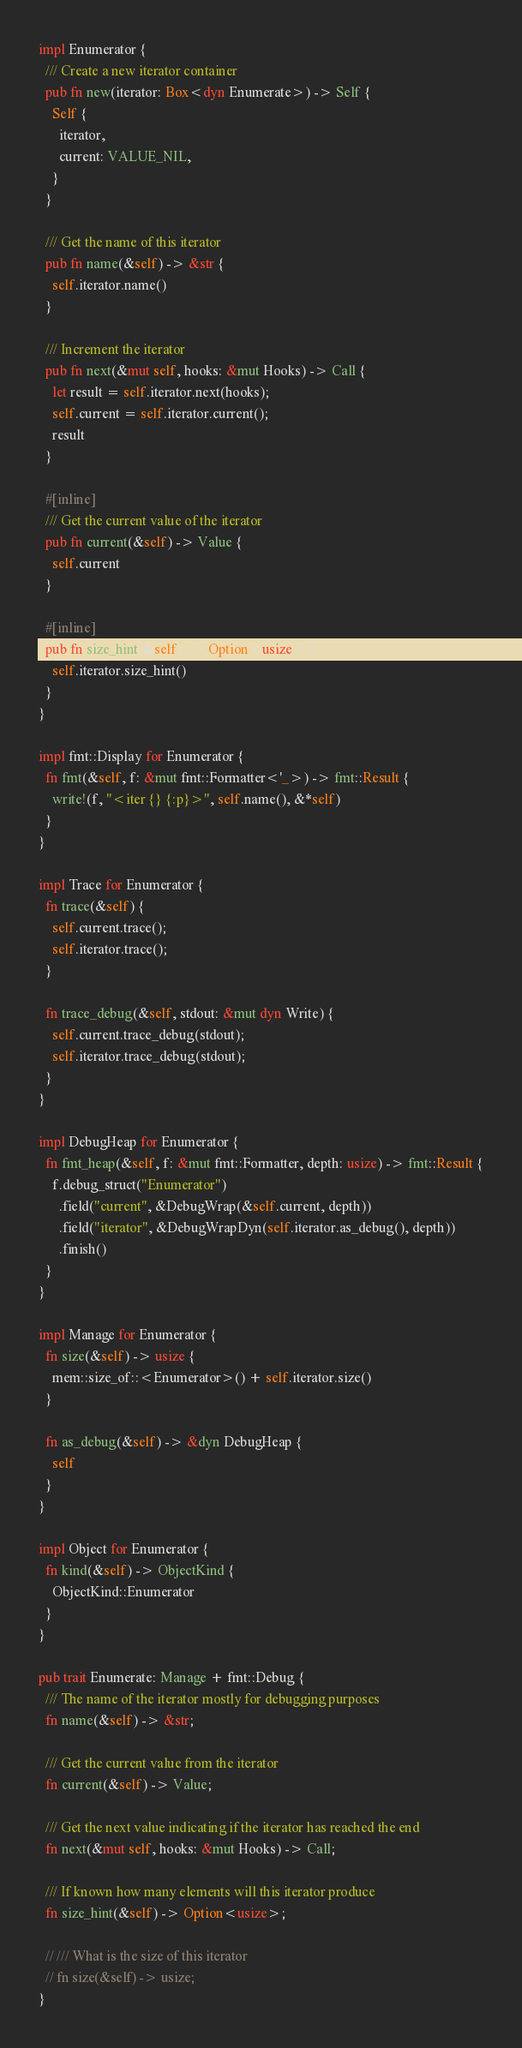Convert code to text. <code><loc_0><loc_0><loc_500><loc_500><_Rust_>
impl Enumerator {
  /// Create a new iterator container
  pub fn new(iterator: Box<dyn Enumerate>) -> Self {
    Self {
      iterator,
      current: VALUE_NIL,
    }
  }

  /// Get the name of this iterator
  pub fn name(&self) -> &str {
    self.iterator.name()
  }

  /// Increment the iterator
  pub fn next(&mut self, hooks: &mut Hooks) -> Call {
    let result = self.iterator.next(hooks);
    self.current = self.iterator.current();
    result
  }

  #[inline]
  /// Get the current value of the iterator
  pub fn current(&self) -> Value {
    self.current
  }

  #[inline]
  pub fn size_hint(&self) -> Option<usize> {
    self.iterator.size_hint()
  }
}

impl fmt::Display for Enumerator {
  fn fmt(&self, f: &mut fmt::Formatter<'_>) -> fmt::Result {
    write!(f, "<iter {} {:p}>", self.name(), &*self)
  }
}

impl Trace for Enumerator {
  fn trace(&self) {
    self.current.trace();
    self.iterator.trace();
  }

  fn trace_debug(&self, stdout: &mut dyn Write) {
    self.current.trace_debug(stdout);
    self.iterator.trace_debug(stdout);
  }
}

impl DebugHeap for Enumerator {
  fn fmt_heap(&self, f: &mut fmt::Formatter, depth: usize) -> fmt::Result {
    f.debug_struct("Enumerator")
      .field("current", &DebugWrap(&self.current, depth))
      .field("iterator", &DebugWrapDyn(self.iterator.as_debug(), depth))
      .finish()
  }
}

impl Manage for Enumerator {
  fn size(&self) -> usize {
    mem::size_of::<Enumerator>() + self.iterator.size()
  }

  fn as_debug(&self) -> &dyn DebugHeap {
    self
  }
}

impl Object for Enumerator {
  fn kind(&self) -> ObjectKind {
    ObjectKind::Enumerator
  }
}

pub trait Enumerate: Manage + fmt::Debug {
  /// The name of the iterator mostly for debugging purposes
  fn name(&self) -> &str;

  /// Get the current value from the iterator
  fn current(&self) -> Value;

  /// Get the next value indicating if the iterator has reached the end
  fn next(&mut self, hooks: &mut Hooks) -> Call;

  /// If known how many elements will this iterator produce
  fn size_hint(&self) -> Option<usize>;

  // /// What is the size of this iterator
  // fn size(&self) -> usize;
}
</code> 